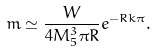Convert formula to latex. <formula><loc_0><loc_0><loc_500><loc_500>m \simeq \frac { W } { 4 M _ { 5 } ^ { 3 } \pi R } e ^ { - R k \pi } .</formula> 